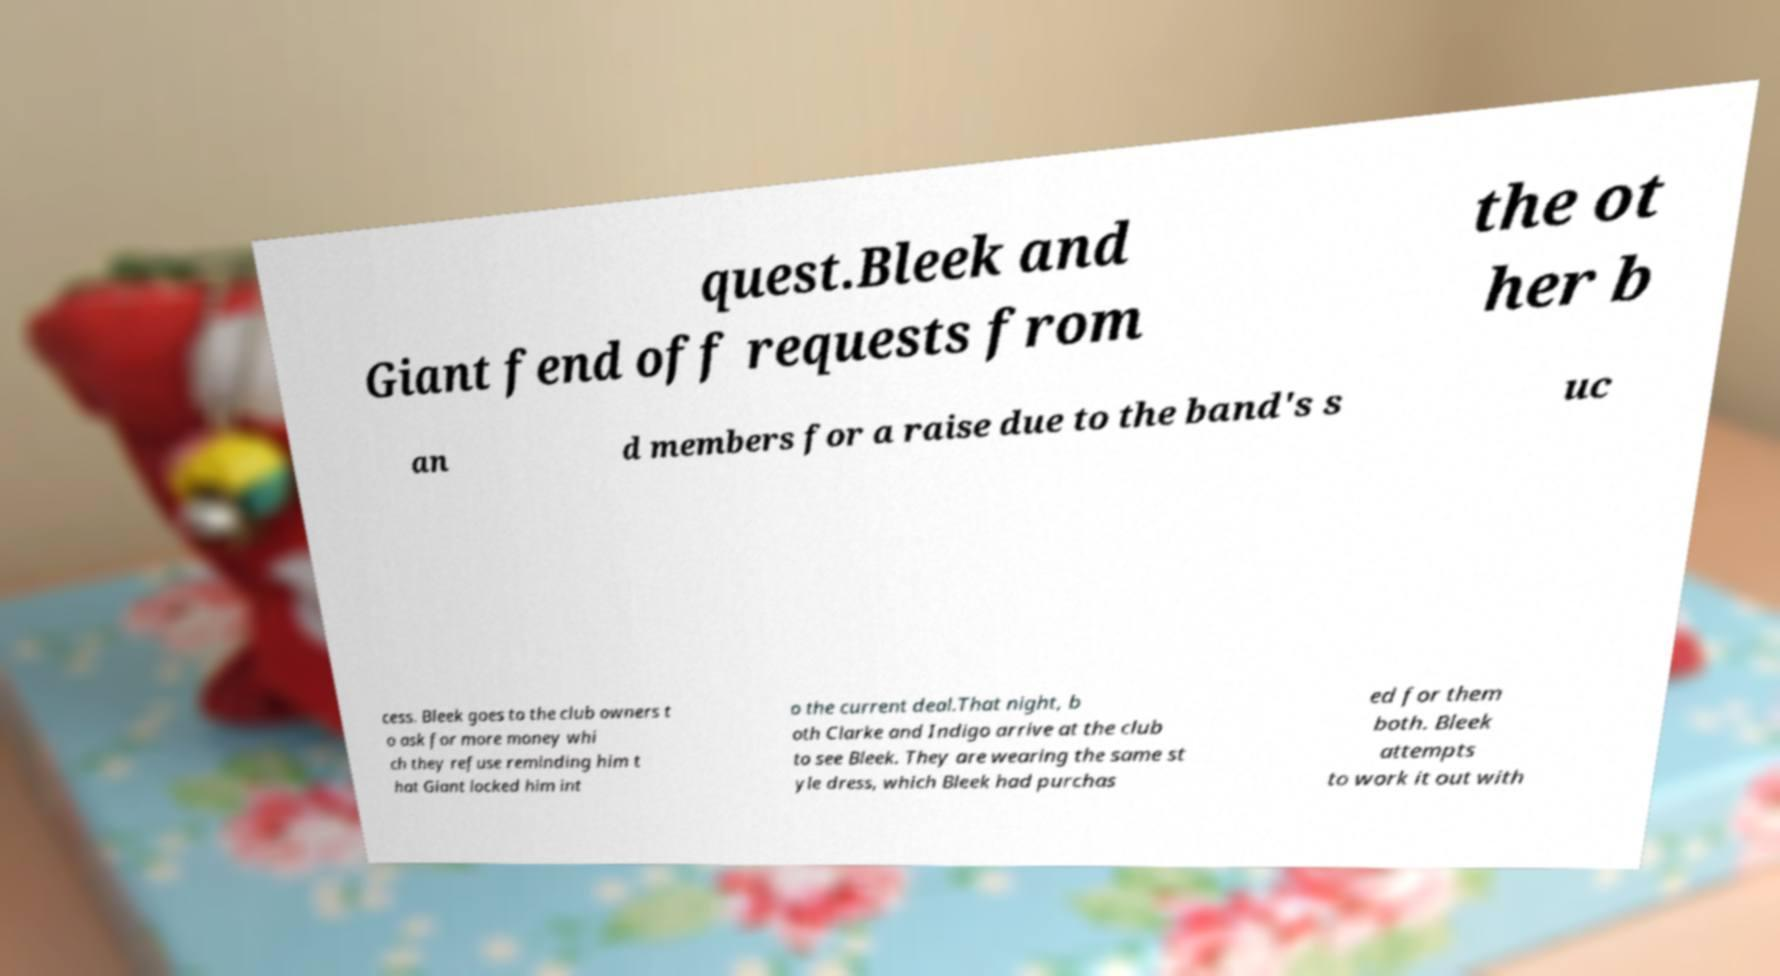Can you accurately transcribe the text from the provided image for me? quest.Bleek and Giant fend off requests from the ot her b an d members for a raise due to the band's s uc cess. Bleek goes to the club owners t o ask for more money whi ch they refuse reminding him t hat Giant locked him int o the current deal.That night, b oth Clarke and Indigo arrive at the club to see Bleek. They are wearing the same st yle dress, which Bleek had purchas ed for them both. Bleek attempts to work it out with 